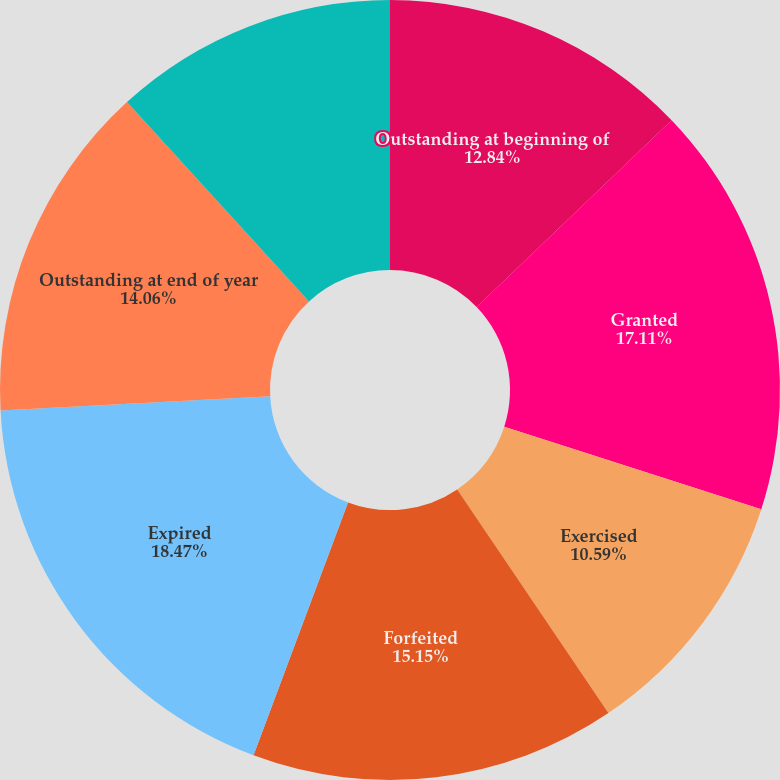<chart> <loc_0><loc_0><loc_500><loc_500><pie_chart><fcel>Outstanding at beginning of<fcel>Granted<fcel>Exercised<fcel>Forfeited<fcel>Expired<fcel>Outstanding at end of year<fcel>Exercisable at end of year<nl><fcel>12.84%<fcel>17.11%<fcel>10.59%<fcel>15.15%<fcel>18.47%<fcel>14.06%<fcel>11.78%<nl></chart> 